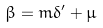<formula> <loc_0><loc_0><loc_500><loc_500>\beta = m \delta ^ { \prime } + \mu</formula> 